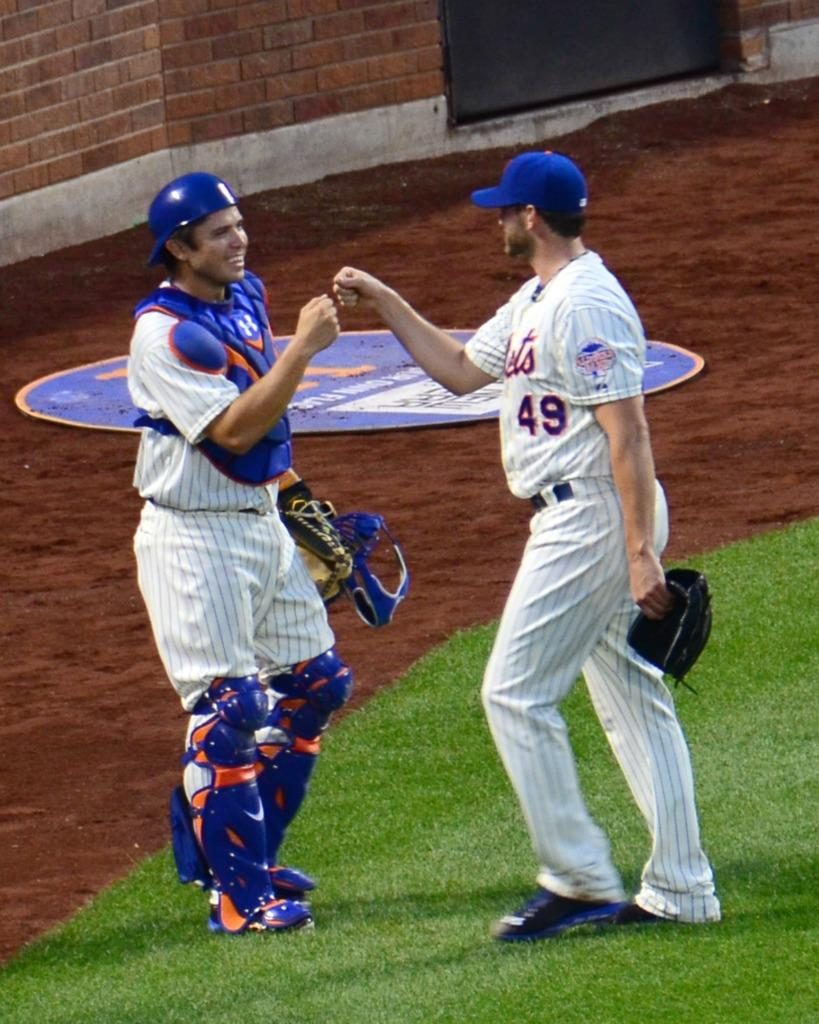<image>
Render a clear and concise summary of the photo. A baseball catcher exchanges a fist bump with a fellow teammate wearing number 49. 